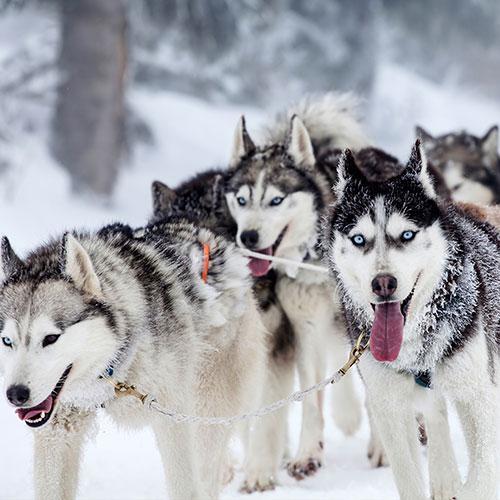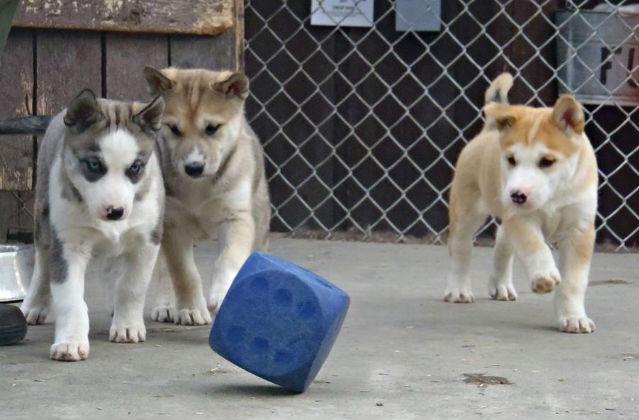The first image is the image on the left, the second image is the image on the right. Given the left and right images, does the statement "Both images in the pair show sled dogs attached to a sled." hold true? Answer yes or no. No. 